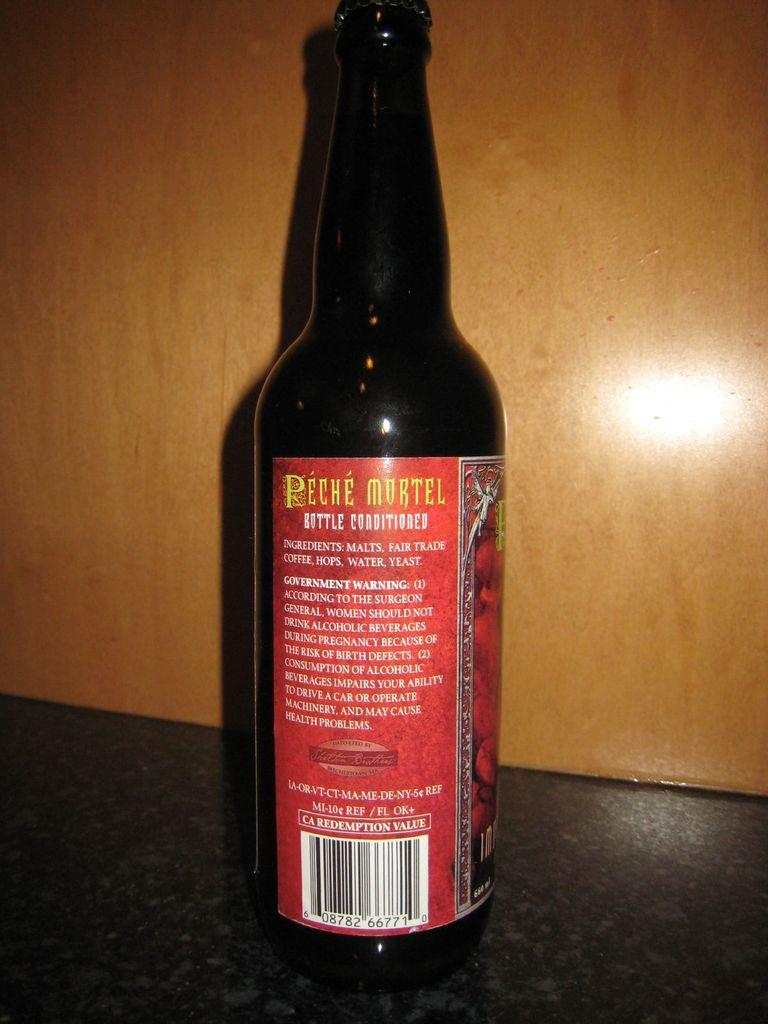Provide a one-sentence caption for the provided image. A bottle on a counter top that shows the back of the label called Peche Mortel. 